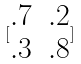Convert formula to latex. <formula><loc_0><loc_0><loc_500><loc_500>[ \begin{matrix} . 7 & . 2 \\ . 3 & . 8 \end{matrix} ]</formula> 